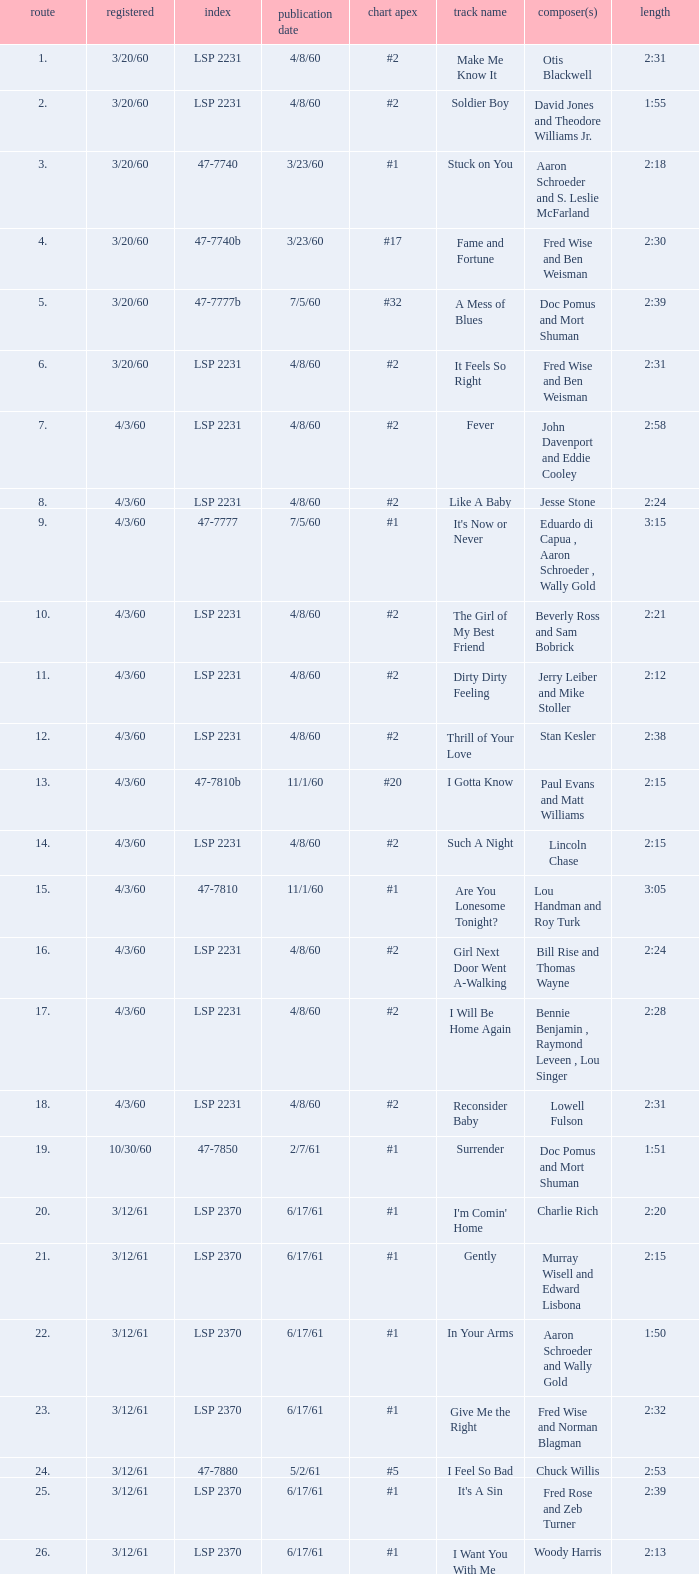What is the time of songs that have the writer Aaron Schroeder and Wally Gold? 1:50. 